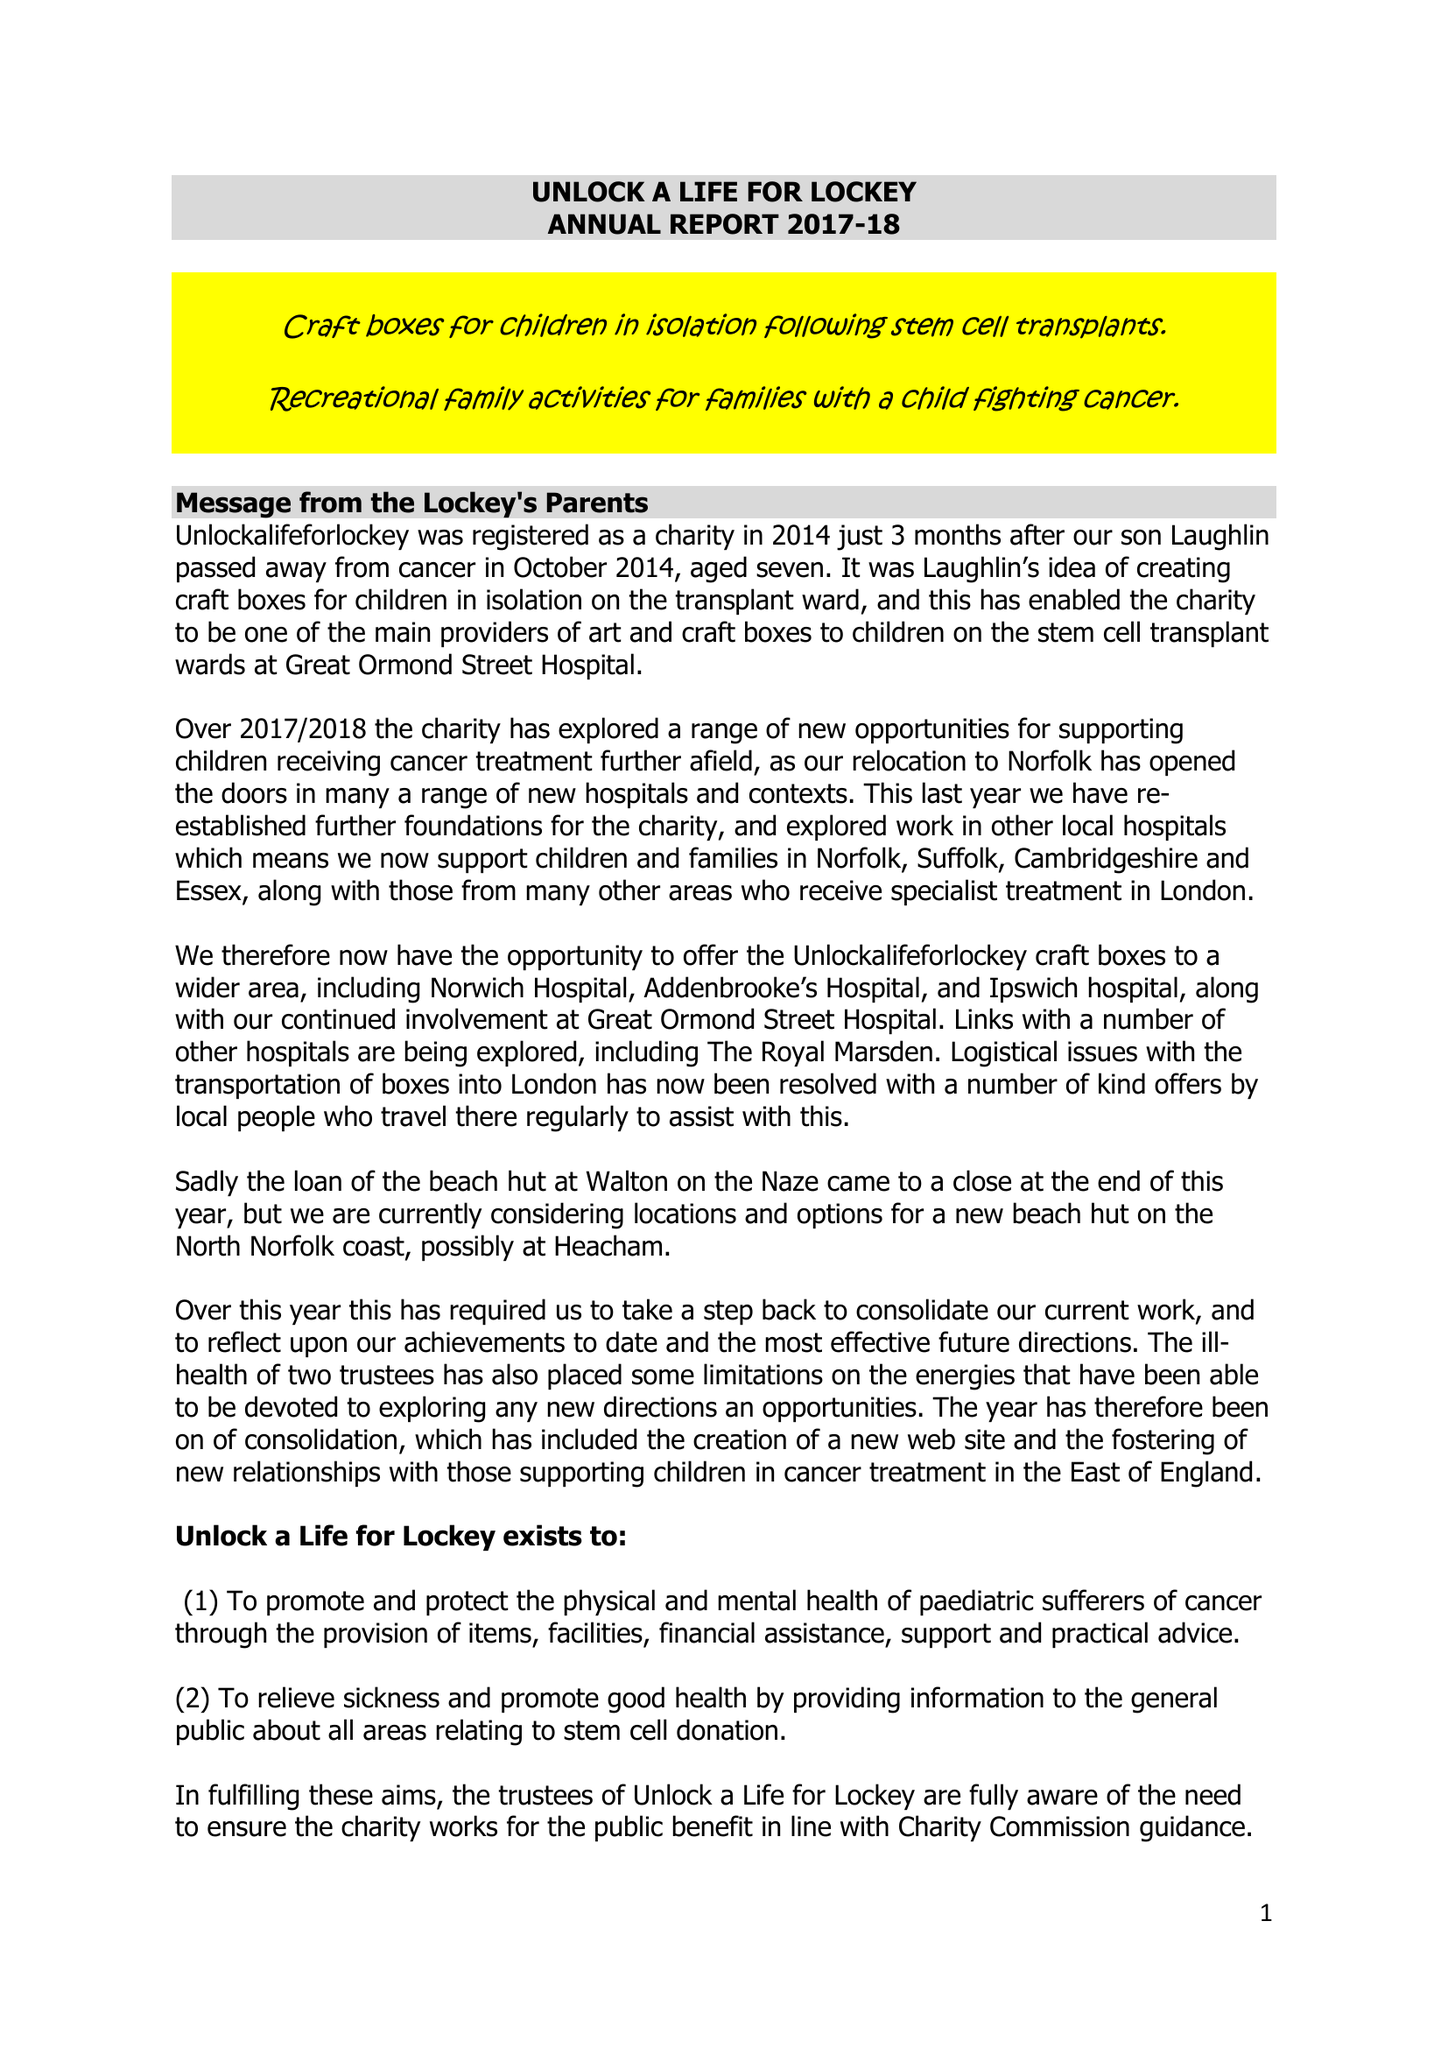What is the value for the charity_number?
Answer the question using a single word or phrase. 1159826 